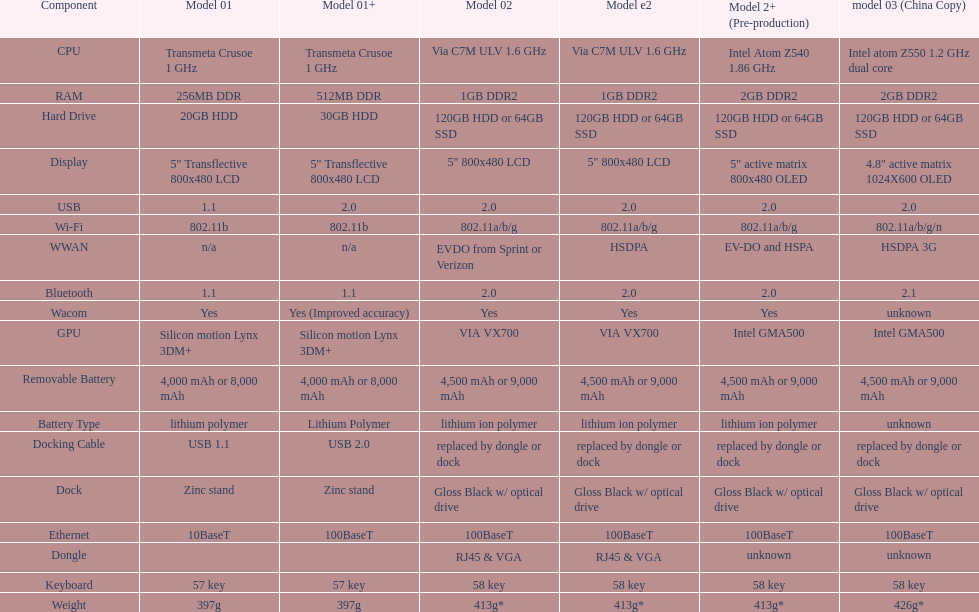From the data in the table, which model's weight is the heaviest? Model 03 (china copy). 